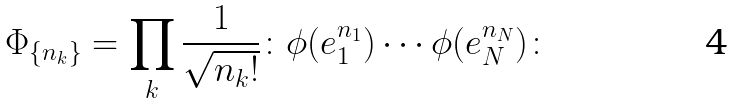Convert formula to latex. <formula><loc_0><loc_0><loc_500><loc_500>\Phi _ { \{ n _ { k } \} } = \prod _ { k } \frac { 1 } { \sqrt { n _ { k } ! } } \colon \phi ( e _ { 1 } ^ { n _ { 1 } } ) \cdots \phi ( e _ { N } ^ { n _ { N } } ) \colon</formula> 